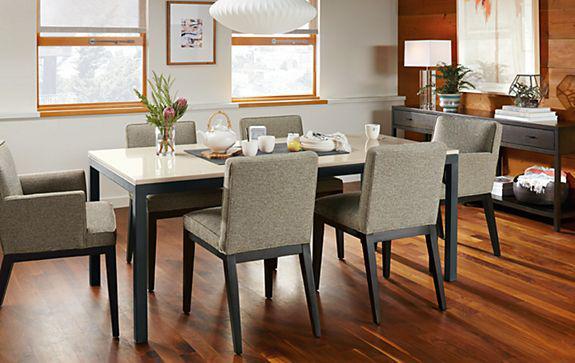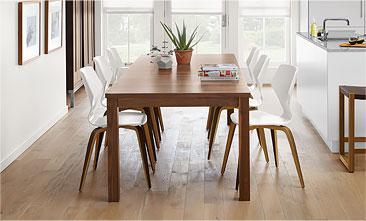The first image is the image on the left, the second image is the image on the right. Given the left and right images, does the statement "In one of the images, there is a dining table and chairs placed over an area rug." hold true? Answer yes or no. No. The first image is the image on the left, the second image is the image on the right. Analyze the images presented: Is the assertion "A rectangular dining table has at least two chairs on each long side." valid? Answer yes or no. Yes. 